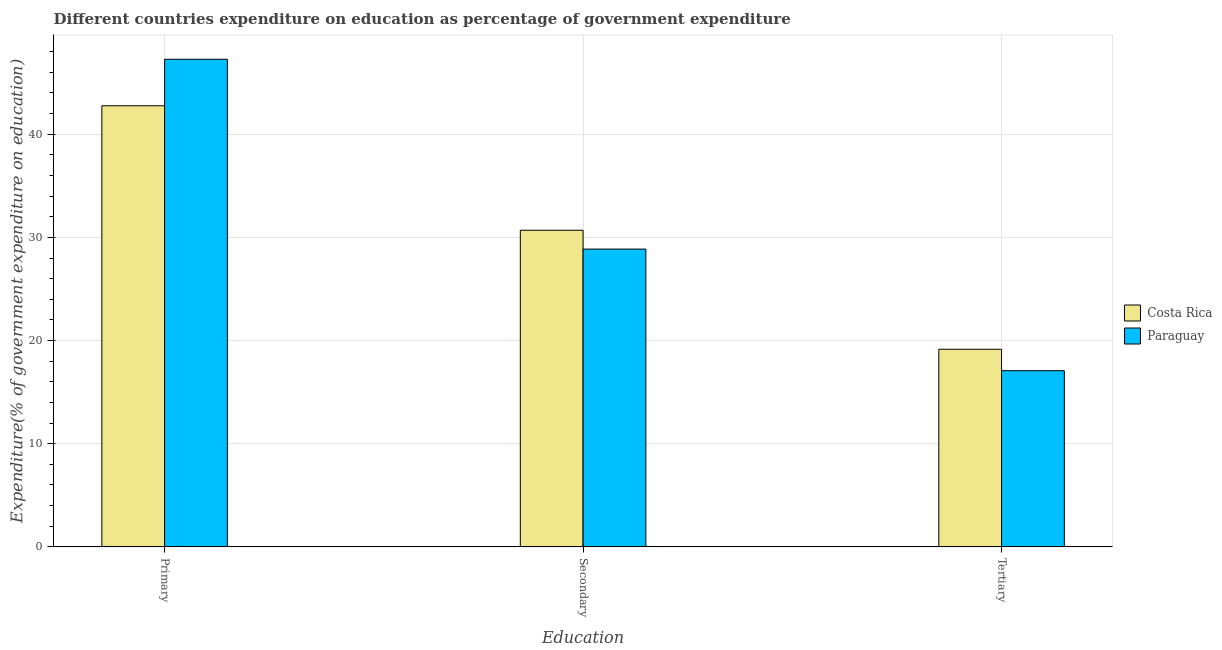Are the number of bars per tick equal to the number of legend labels?
Make the answer very short. Yes. How many bars are there on the 1st tick from the right?
Provide a short and direct response. 2. What is the label of the 3rd group of bars from the left?
Offer a terse response. Tertiary. What is the expenditure on primary education in Costa Rica?
Provide a succinct answer. 42.76. Across all countries, what is the maximum expenditure on tertiary education?
Keep it short and to the point. 19.16. Across all countries, what is the minimum expenditure on secondary education?
Your answer should be compact. 28.86. In which country was the expenditure on primary education minimum?
Give a very brief answer. Costa Rica. What is the total expenditure on primary education in the graph?
Give a very brief answer. 90.02. What is the difference between the expenditure on primary education in Paraguay and that in Costa Rica?
Your answer should be very brief. 4.51. What is the difference between the expenditure on primary education in Paraguay and the expenditure on tertiary education in Costa Rica?
Your answer should be compact. 28.11. What is the average expenditure on secondary education per country?
Your answer should be compact. 29.78. What is the difference between the expenditure on primary education and expenditure on tertiary education in Costa Rica?
Provide a short and direct response. 23.6. In how many countries, is the expenditure on primary education greater than 4 %?
Your answer should be very brief. 2. What is the ratio of the expenditure on secondary education in Paraguay to that in Costa Rica?
Your answer should be compact. 0.94. Is the expenditure on tertiary education in Paraguay less than that in Costa Rica?
Ensure brevity in your answer.  Yes. What is the difference between the highest and the second highest expenditure on primary education?
Offer a very short reply. 4.51. What is the difference between the highest and the lowest expenditure on primary education?
Ensure brevity in your answer.  4.51. In how many countries, is the expenditure on secondary education greater than the average expenditure on secondary education taken over all countries?
Provide a short and direct response. 1. Is the sum of the expenditure on tertiary education in Paraguay and Costa Rica greater than the maximum expenditure on primary education across all countries?
Keep it short and to the point. No. What does the 2nd bar from the left in Primary represents?
Keep it short and to the point. Paraguay. How many bars are there?
Make the answer very short. 6. Are the values on the major ticks of Y-axis written in scientific E-notation?
Your response must be concise. No. Does the graph contain grids?
Provide a succinct answer. Yes. Where does the legend appear in the graph?
Offer a terse response. Center right. How many legend labels are there?
Make the answer very short. 2. What is the title of the graph?
Your answer should be compact. Different countries expenditure on education as percentage of government expenditure. Does "Austria" appear as one of the legend labels in the graph?
Provide a succinct answer. No. What is the label or title of the X-axis?
Give a very brief answer. Education. What is the label or title of the Y-axis?
Offer a very short reply. Expenditure(% of government expenditure on education). What is the Expenditure(% of government expenditure on education) in Costa Rica in Primary?
Keep it short and to the point. 42.76. What is the Expenditure(% of government expenditure on education) in Paraguay in Primary?
Your answer should be very brief. 47.27. What is the Expenditure(% of government expenditure on education) of Costa Rica in Secondary?
Provide a short and direct response. 30.69. What is the Expenditure(% of government expenditure on education) in Paraguay in Secondary?
Offer a terse response. 28.86. What is the Expenditure(% of government expenditure on education) in Costa Rica in Tertiary?
Your answer should be very brief. 19.16. What is the Expenditure(% of government expenditure on education) in Paraguay in Tertiary?
Offer a terse response. 17.08. Across all Education, what is the maximum Expenditure(% of government expenditure on education) in Costa Rica?
Your answer should be compact. 42.76. Across all Education, what is the maximum Expenditure(% of government expenditure on education) in Paraguay?
Provide a succinct answer. 47.27. Across all Education, what is the minimum Expenditure(% of government expenditure on education) of Costa Rica?
Provide a short and direct response. 19.16. Across all Education, what is the minimum Expenditure(% of government expenditure on education) of Paraguay?
Your answer should be very brief. 17.08. What is the total Expenditure(% of government expenditure on education) of Costa Rica in the graph?
Make the answer very short. 92.6. What is the total Expenditure(% of government expenditure on education) in Paraguay in the graph?
Keep it short and to the point. 93.21. What is the difference between the Expenditure(% of government expenditure on education) in Costa Rica in Primary and that in Secondary?
Provide a short and direct response. 12.07. What is the difference between the Expenditure(% of government expenditure on education) in Paraguay in Primary and that in Secondary?
Make the answer very short. 18.4. What is the difference between the Expenditure(% of government expenditure on education) in Costa Rica in Primary and that in Tertiary?
Offer a terse response. 23.6. What is the difference between the Expenditure(% of government expenditure on education) of Paraguay in Primary and that in Tertiary?
Your answer should be very brief. 30.19. What is the difference between the Expenditure(% of government expenditure on education) in Costa Rica in Secondary and that in Tertiary?
Your answer should be compact. 11.53. What is the difference between the Expenditure(% of government expenditure on education) of Paraguay in Secondary and that in Tertiary?
Your answer should be compact. 11.79. What is the difference between the Expenditure(% of government expenditure on education) of Costa Rica in Primary and the Expenditure(% of government expenditure on education) of Paraguay in Secondary?
Keep it short and to the point. 13.89. What is the difference between the Expenditure(% of government expenditure on education) of Costa Rica in Primary and the Expenditure(% of government expenditure on education) of Paraguay in Tertiary?
Provide a short and direct response. 25.68. What is the difference between the Expenditure(% of government expenditure on education) of Costa Rica in Secondary and the Expenditure(% of government expenditure on education) of Paraguay in Tertiary?
Ensure brevity in your answer.  13.61. What is the average Expenditure(% of government expenditure on education) in Costa Rica per Education?
Offer a very short reply. 30.87. What is the average Expenditure(% of government expenditure on education) of Paraguay per Education?
Provide a short and direct response. 31.07. What is the difference between the Expenditure(% of government expenditure on education) of Costa Rica and Expenditure(% of government expenditure on education) of Paraguay in Primary?
Your answer should be very brief. -4.51. What is the difference between the Expenditure(% of government expenditure on education) in Costa Rica and Expenditure(% of government expenditure on education) in Paraguay in Secondary?
Make the answer very short. 1.83. What is the difference between the Expenditure(% of government expenditure on education) in Costa Rica and Expenditure(% of government expenditure on education) in Paraguay in Tertiary?
Keep it short and to the point. 2.08. What is the ratio of the Expenditure(% of government expenditure on education) in Costa Rica in Primary to that in Secondary?
Provide a short and direct response. 1.39. What is the ratio of the Expenditure(% of government expenditure on education) of Paraguay in Primary to that in Secondary?
Provide a short and direct response. 1.64. What is the ratio of the Expenditure(% of government expenditure on education) of Costa Rica in Primary to that in Tertiary?
Give a very brief answer. 2.23. What is the ratio of the Expenditure(% of government expenditure on education) of Paraguay in Primary to that in Tertiary?
Your answer should be very brief. 2.77. What is the ratio of the Expenditure(% of government expenditure on education) of Costa Rica in Secondary to that in Tertiary?
Provide a succinct answer. 1.6. What is the ratio of the Expenditure(% of government expenditure on education) in Paraguay in Secondary to that in Tertiary?
Your answer should be compact. 1.69. What is the difference between the highest and the second highest Expenditure(% of government expenditure on education) in Costa Rica?
Your answer should be very brief. 12.07. What is the difference between the highest and the second highest Expenditure(% of government expenditure on education) of Paraguay?
Your answer should be compact. 18.4. What is the difference between the highest and the lowest Expenditure(% of government expenditure on education) in Costa Rica?
Make the answer very short. 23.6. What is the difference between the highest and the lowest Expenditure(% of government expenditure on education) in Paraguay?
Your response must be concise. 30.19. 